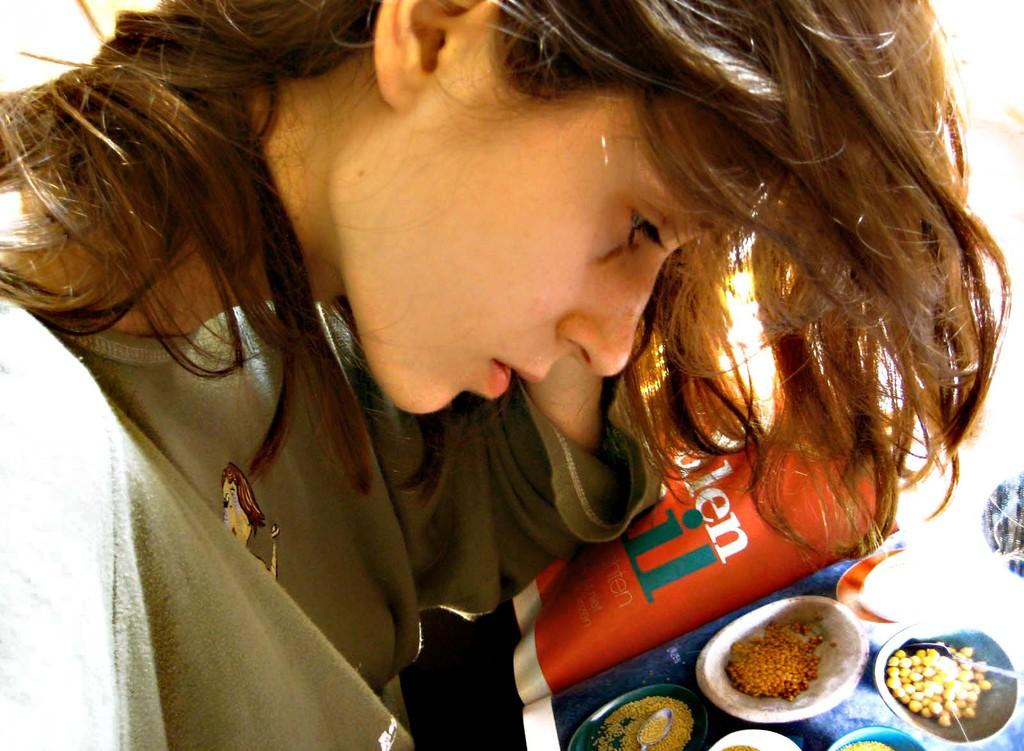Who is the main subject in the image? There is a girl in the center of the image. What is located in front of the girl? There is a pamphlet in front of the girl. How many fire hydrants can be seen in the image? There are no fire hydrants present in the image. What type of base is supporting the girl in the image? The girl is standing on her own two feet, and there is no base supporting her in the image. 